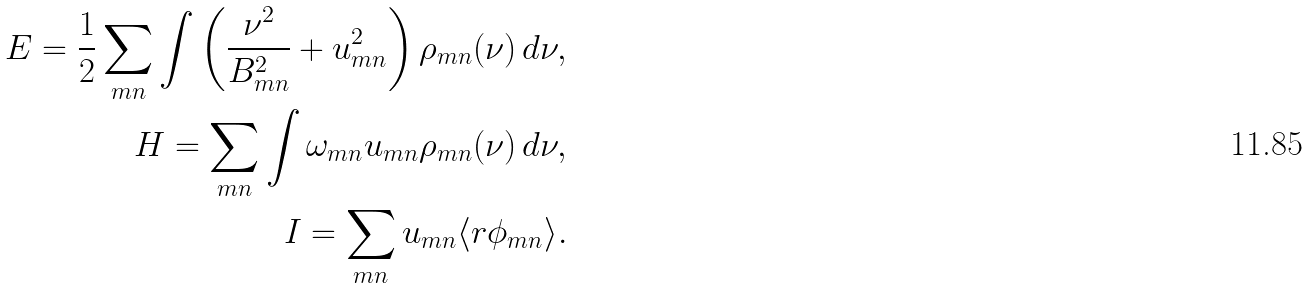Convert formula to latex. <formula><loc_0><loc_0><loc_500><loc_500>E = \frac { 1 } { 2 } \sum _ { m n } \int \left ( \frac { \nu ^ { 2 } } { B _ { m n } ^ { 2 } } + u _ { m n } ^ { 2 } \right ) \rho _ { m n } ( \nu ) \, d \nu , \\ H = \sum _ { m n } \int \omega _ { m n } u _ { m n } \rho _ { m n } ( \nu ) \, d \nu , \\ I = \sum _ { m n } u _ { m n } \langle r \phi _ { m n } \rangle .</formula> 